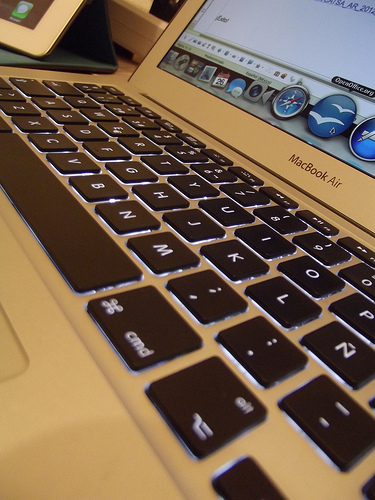<image>
Is there a tablet behind the macbook? No. The tablet is not behind the macbook. From this viewpoint, the tablet appears to be positioned elsewhere in the scene. 